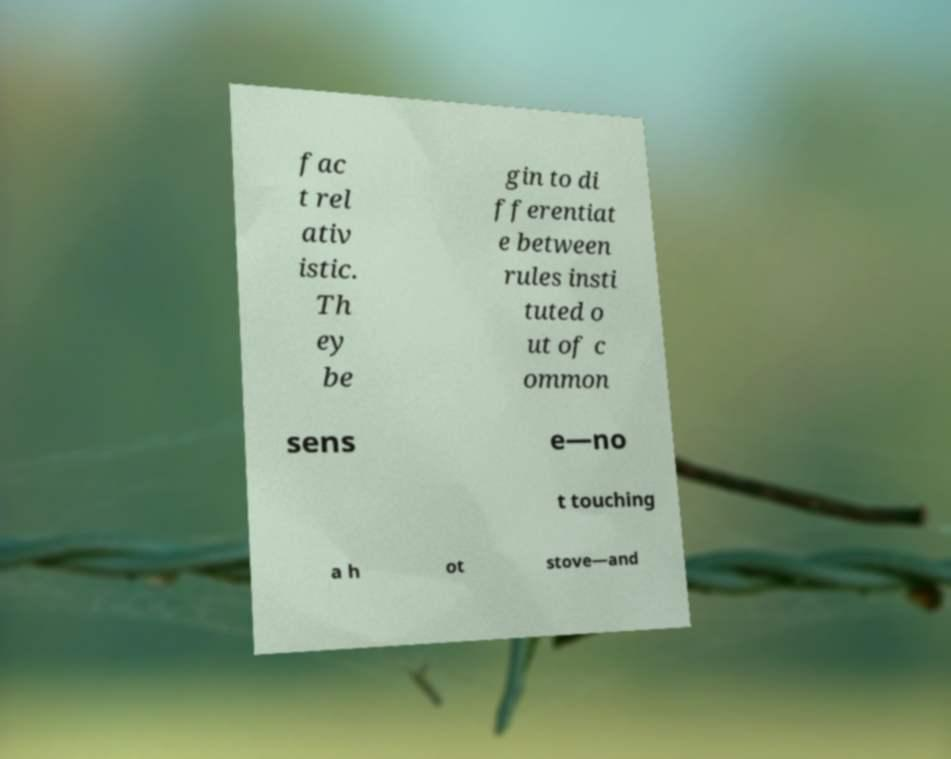There's text embedded in this image that I need extracted. Can you transcribe it verbatim? fac t rel ativ istic. Th ey be gin to di fferentiat e between rules insti tuted o ut of c ommon sens e—no t touching a h ot stove—and 